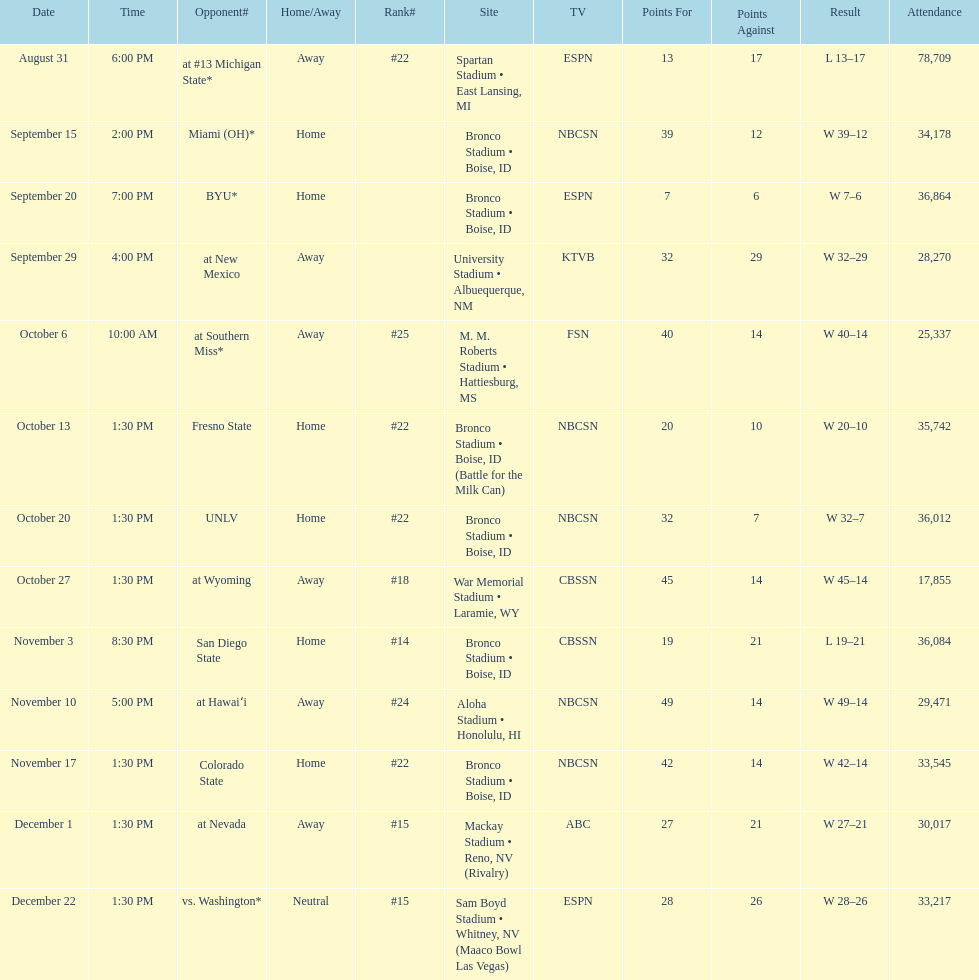What was there top ranked position of the season? #14. 